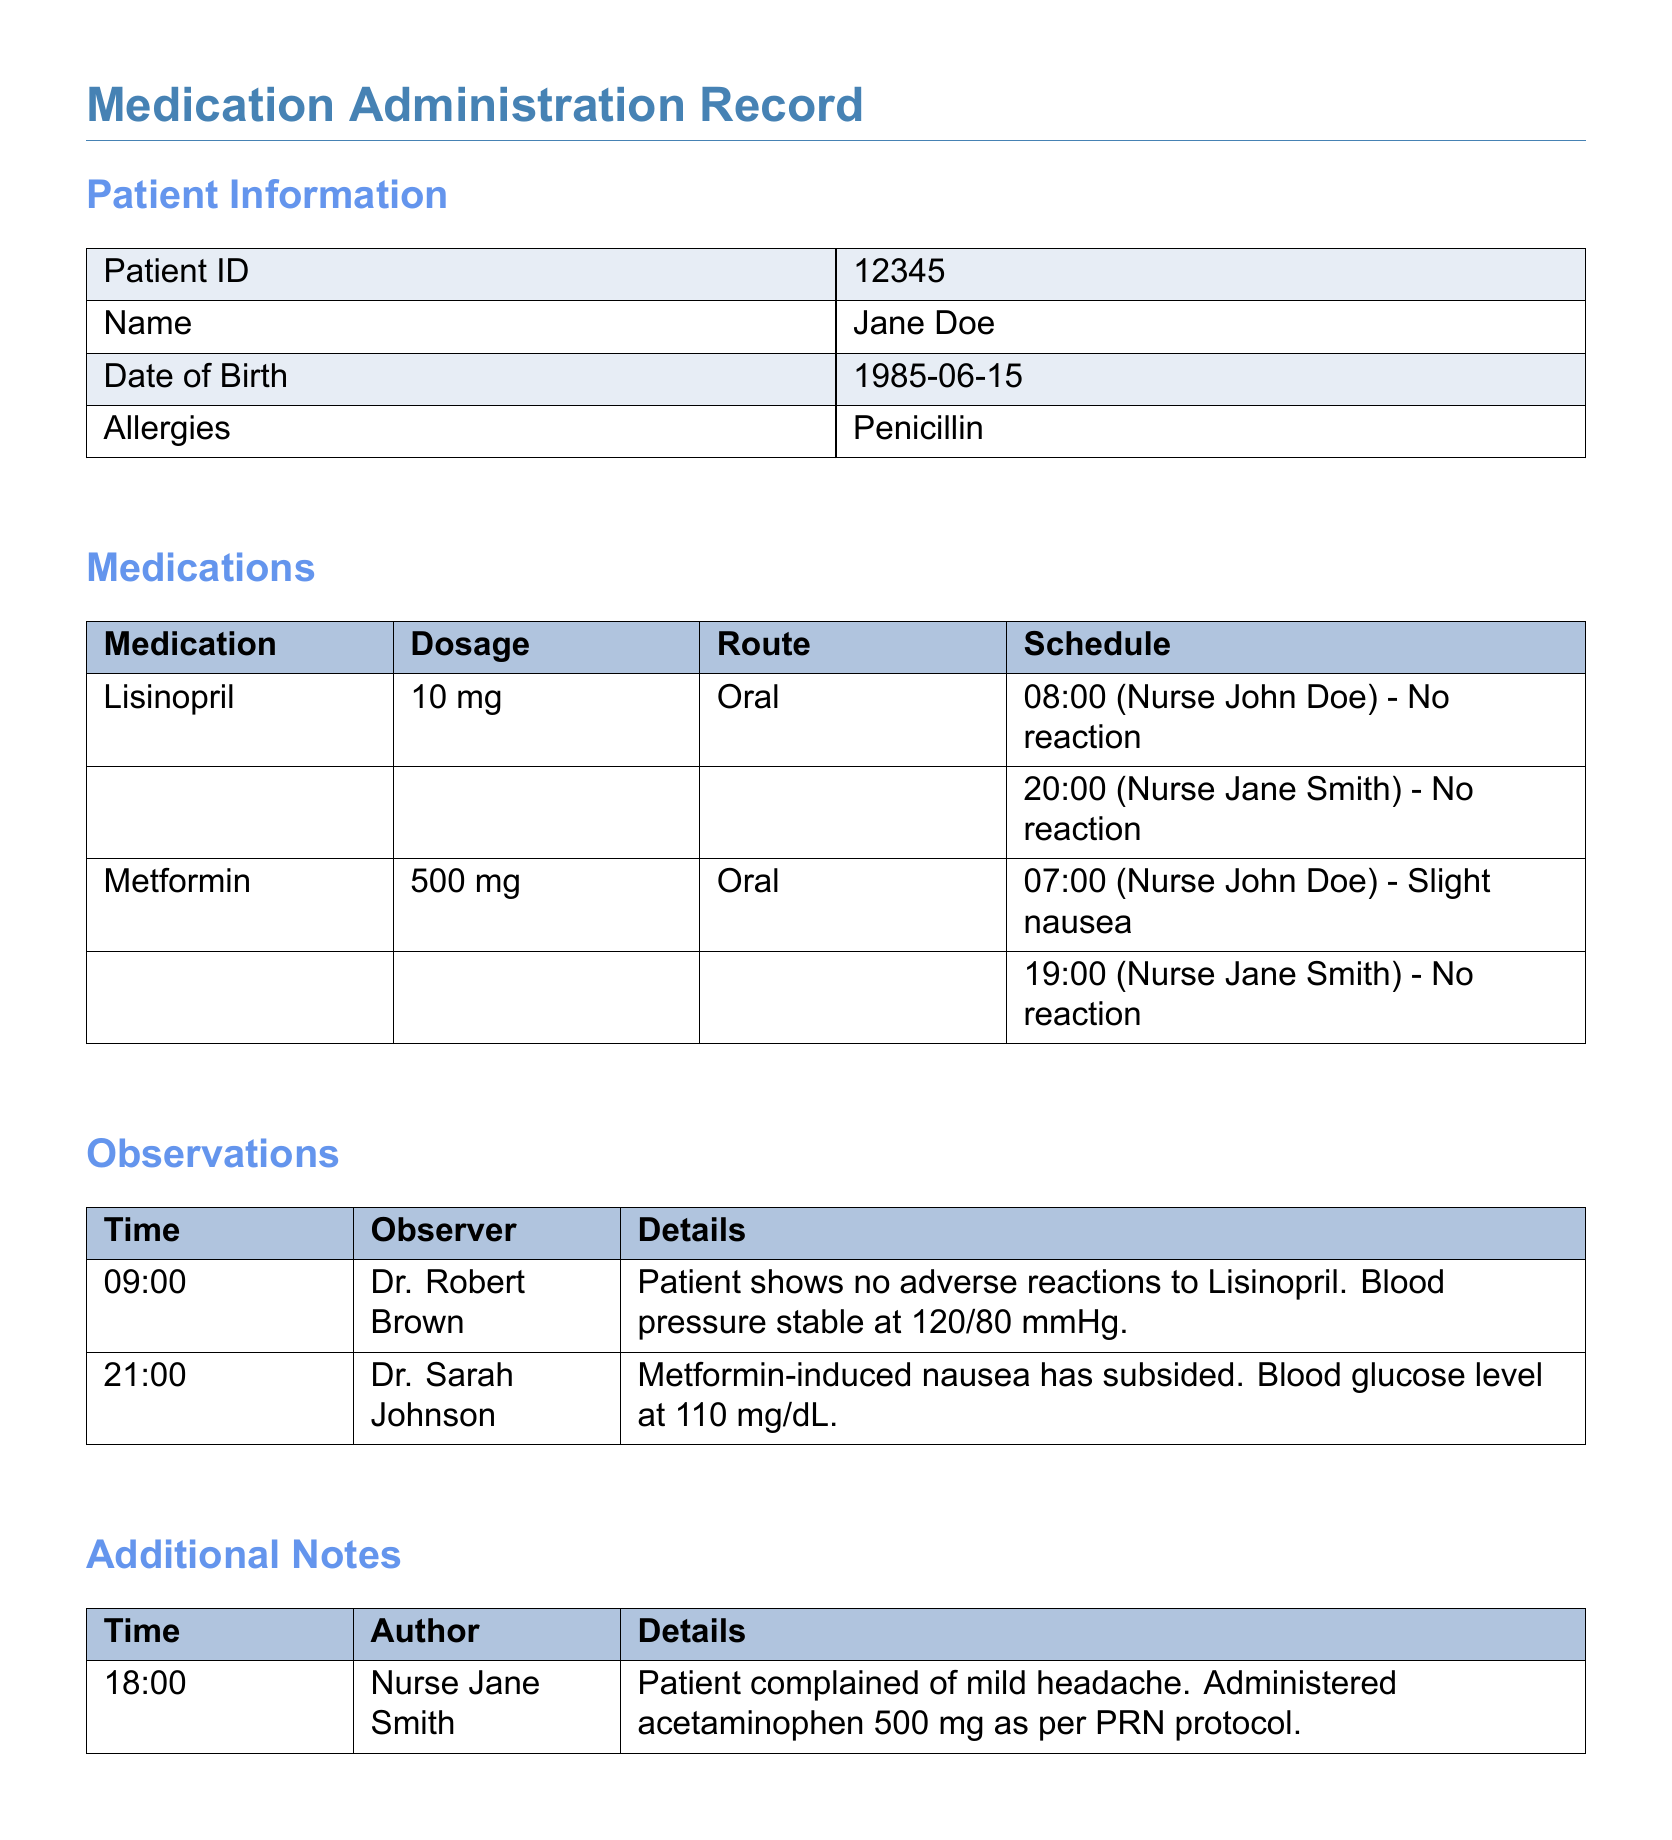What is the Patient ID? The Patient ID is listed in the Patient Information section of the document.
Answer: 12345 What is the first medication listed? The first medication is found in the Medications section.
Answer: Lisinopril What is the dosage of Metformin? The dosage of Metformin is detailed in the Medications table.
Answer: 500 mg Who observed the patient at 09:00? The observer at 09:00 is recorded under the Observations section.
Answer: Dr. Robert Brown What was administered for the patient's headache? The Additional Notes section specifies the treatment for the headache.
Answer: Acetaminophen 500 mg What reaction did the patient have to Metformin at 07:00? The reaction to Metformin at 07:00 is noted in the Medications section.
Answer: Slight nausea At what time did Nurse Jane Smith log the last medication administration? The time is listed in the Medications section under the schedule for Lisinopril.
Answer: 20:00 What was the blood pressure reading observed at 09:00? The reading is mentioned in the Observations section.
Answer: 120/80 mmHg What is the allergy listed for the patient? The allergy information is found in the Patient Information section.
Answer: Penicillin 